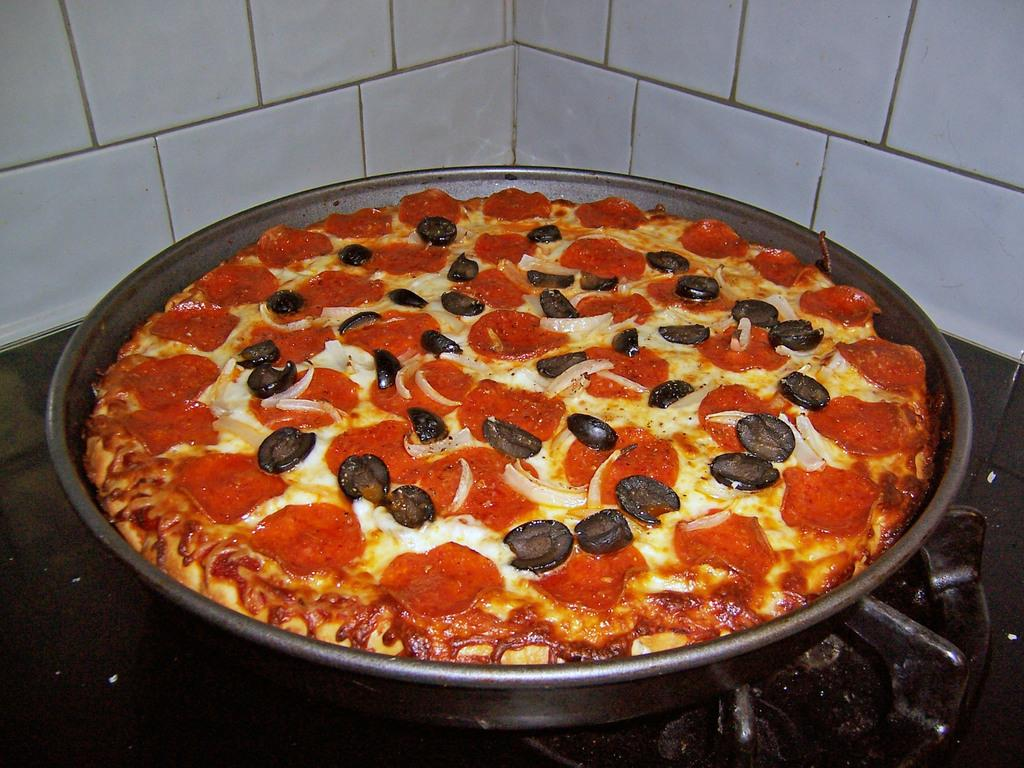What is in the bowl that is visible in the image? The bowl contains pizza. What type of food is in the bowl? The food in the bowl is pizza. What is the color of the wall visible in the image? The wall visible in the image is white-colored. What family members are present in the image? There are no family members present in the image; it only shows a bowl of pizza and a white-colored wall. 